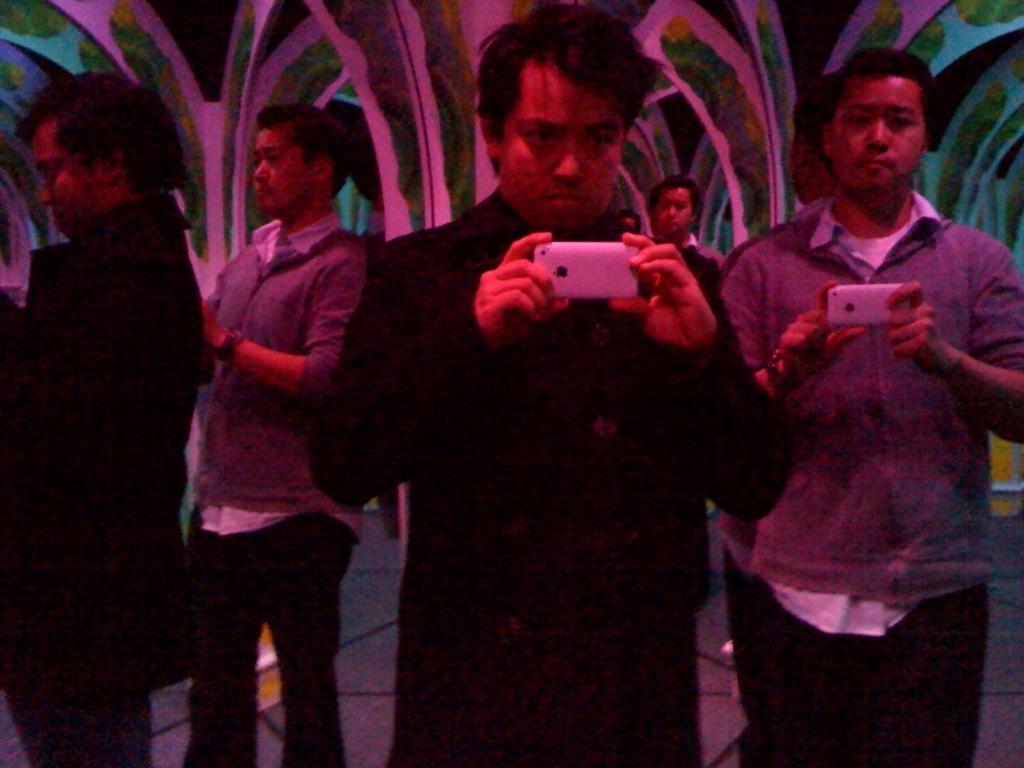What are the people in the image doing? The people in the image are standing and holding phones. What might the people be doing with their phones? They might be taking pictures, making calls, or using various apps on their phones. What can be seen in the background of the image? There is a painted wall visible in the background of the image. What religious symbols can be seen on the wall in the image? There is no mention of religious symbols in the provided facts, and the wall is described as painted, not featuring any specific symbols. 